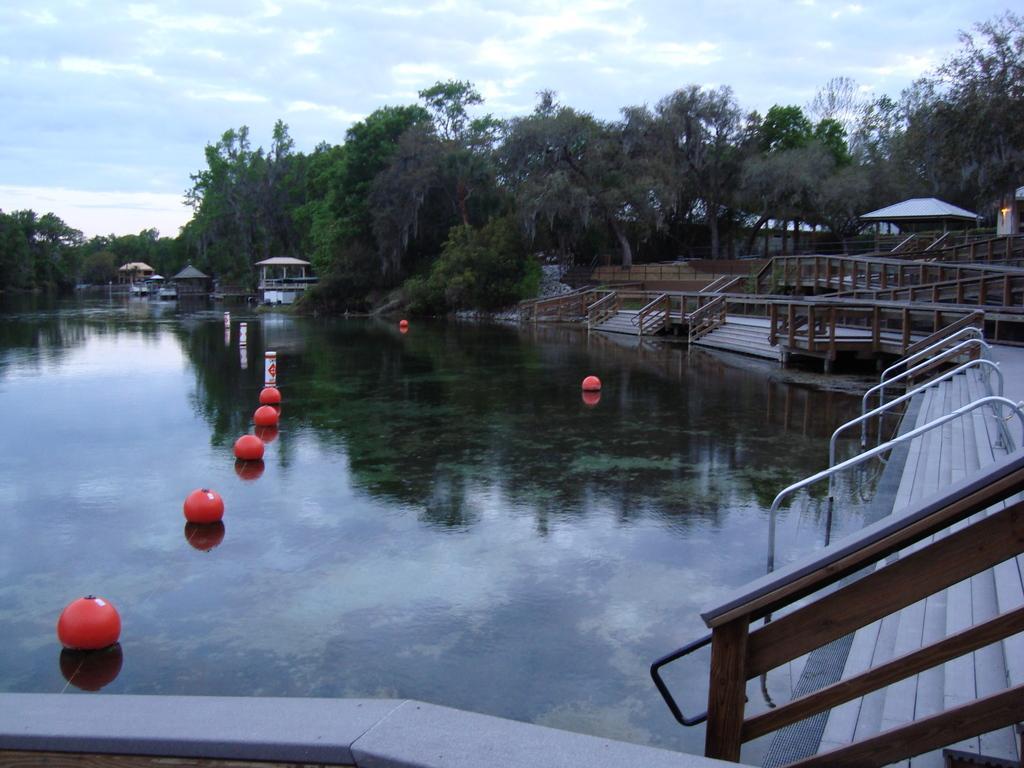Can you describe this image briefly? These are the stairs with the staircase holder. I can see a water flowing. These look like shelters. I can see the trees with branches and leaves. I think these are the objects and the water. 